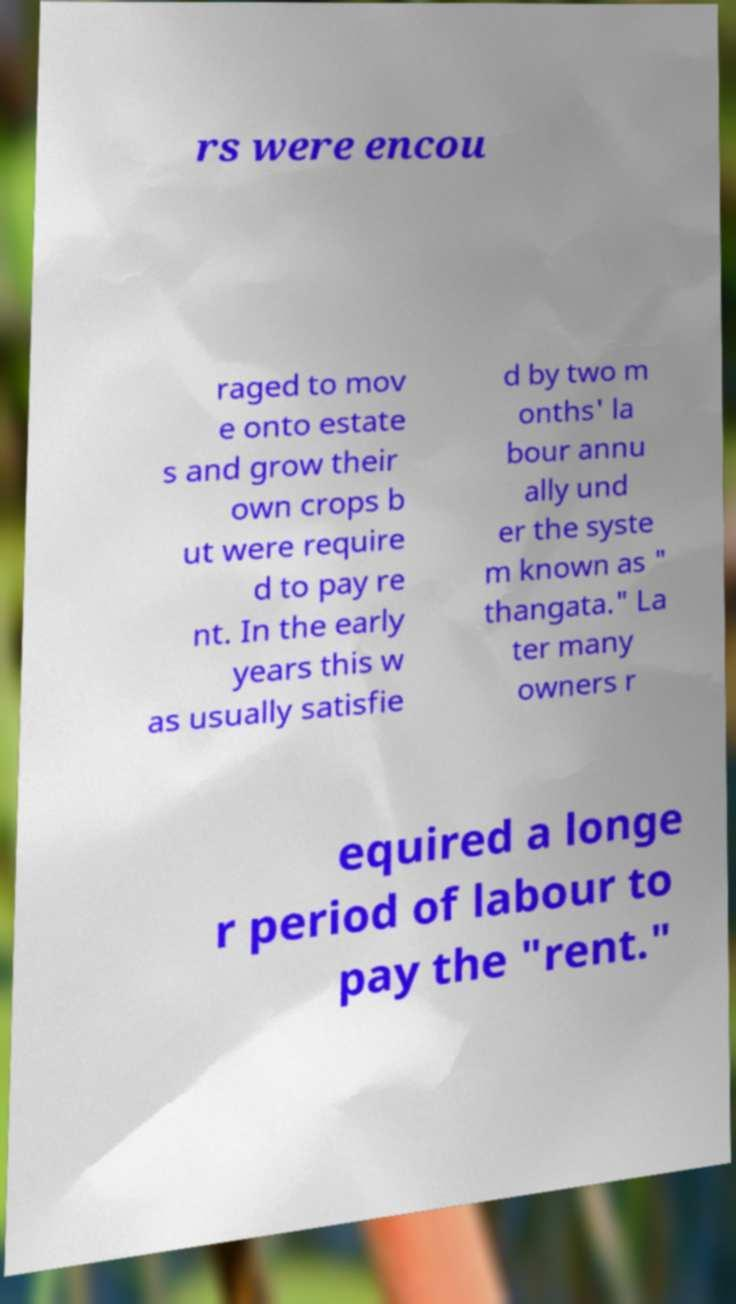Please identify and transcribe the text found in this image. rs were encou raged to mov e onto estate s and grow their own crops b ut were require d to pay re nt. In the early years this w as usually satisfie d by two m onths' la bour annu ally und er the syste m known as " thangata." La ter many owners r equired a longe r period of labour to pay the "rent." 